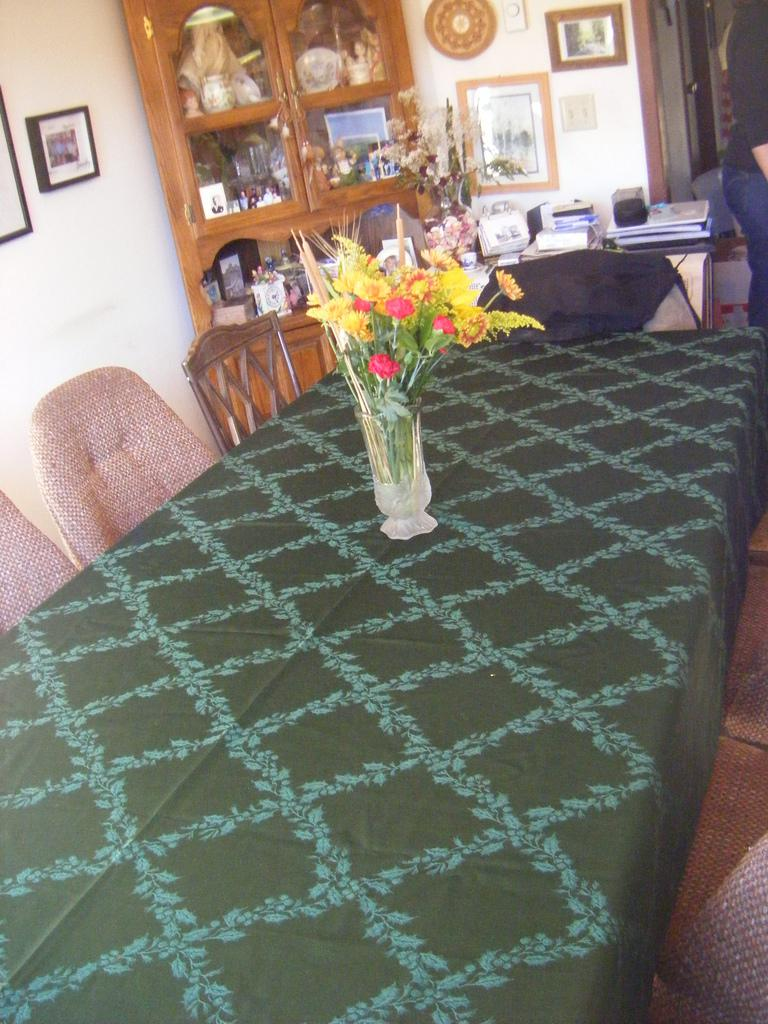Question: what way are the flowers tilted?
Choices:
A. Left.
B. Right.
C. Up.
D. Down.
Answer with the letter. Answer: B Question: how many buttons are seen on the padded chair?
Choices:
A. Four.
B. Six.
C. Nine.
D. Two.
Answer with the letter. Answer: D Question: what color is the table cloth?
Choices:
A. White.
B. Red.
C. Blue.
D. Green.
Answer with the letter. Answer: D Question: who is in the photo?
Choices:
A. A man.
B. One person.
C. A woman.
D. A child.
Answer with the letter. Answer: B Question: what is on the table?
Choices:
A. A plant.
B. A centerpiece.
C. Flowers.
D. A floral arrangement.
Answer with the letter. Answer: C Question: when is the photo taken?
Choices:
A. Morning.
B. Day time.
C. Afternoon.
D. Dusk.
Answer with the letter. Answer: B Question: where is this happening?
Choices:
A. Field.
B. House.
C. Forest.
D. Park.
Answer with the letter. Answer: B Question: what covers the wall?
Choices:
A. Photos.
B. Paintings.
C. Wallpaper.
D. Pictures.
Answer with the letter. Answer: D Question: why are the chairs not a set?
Choices:
A. Some chairs are broken.
B. The chairs are the same size.
C. The chairs match.
D. They are mismatched.
Answer with the letter. Answer: D Question: what color are the flowers?
Choices:
A. Blue and White.
B. Pink and White.
C. Yellow and pink.
D. Red.
Answer with the letter. Answer: C Question: where is the light switch?
Choices:
A. On the near wall.
B. On the far wall.
C. On the side wall.
D. On the back wall.
Answer with the letter. Answer: D Question: where is the photo taken?
Choices:
A. Kitchen.
B. At the table.
C. In a dinning room.
D. Restaraunt.
Answer with the letter. Answer: C Question: what hangs on the walls?
Choices:
A. Clocks.
B. Pictures.
C. Dust.
D. Signs.
Answer with the letter. Answer: B Question: what has a trellis leaf pattern?
Choices:
A. The tablecloth.
B. The napkin.
C. The placemat.
D. The table linens.
Answer with the letter. Answer: A 